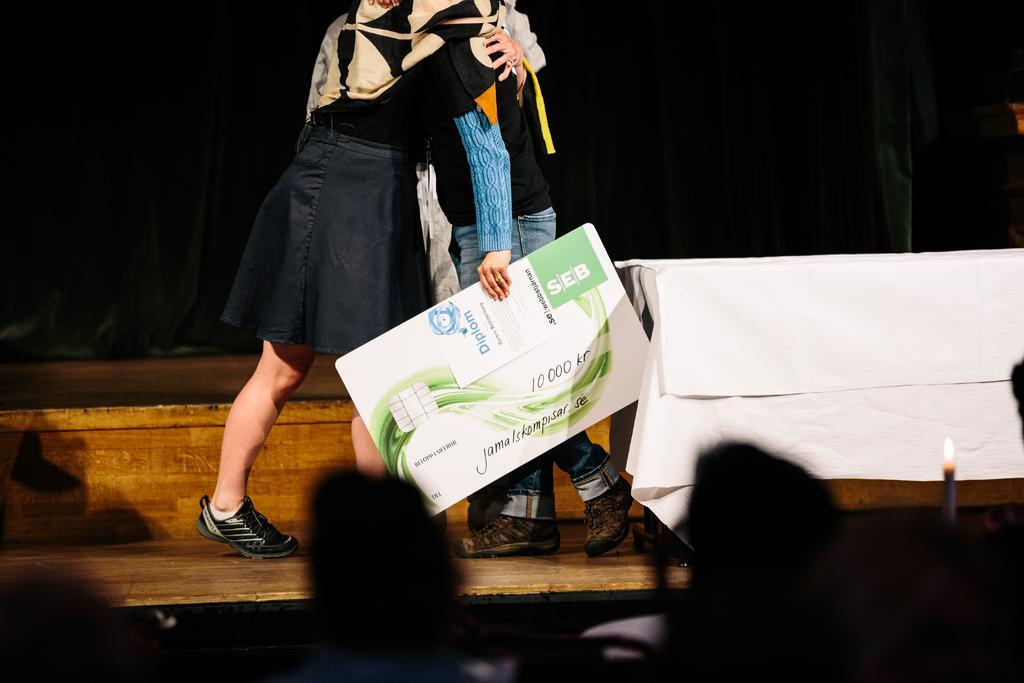Can you describe this image briefly? In this image I can see two people standing, the person on the right side is holding a board in her hands with some text. I can see a table beside her. At the bottom of the image I can see some people standing with candles.. 